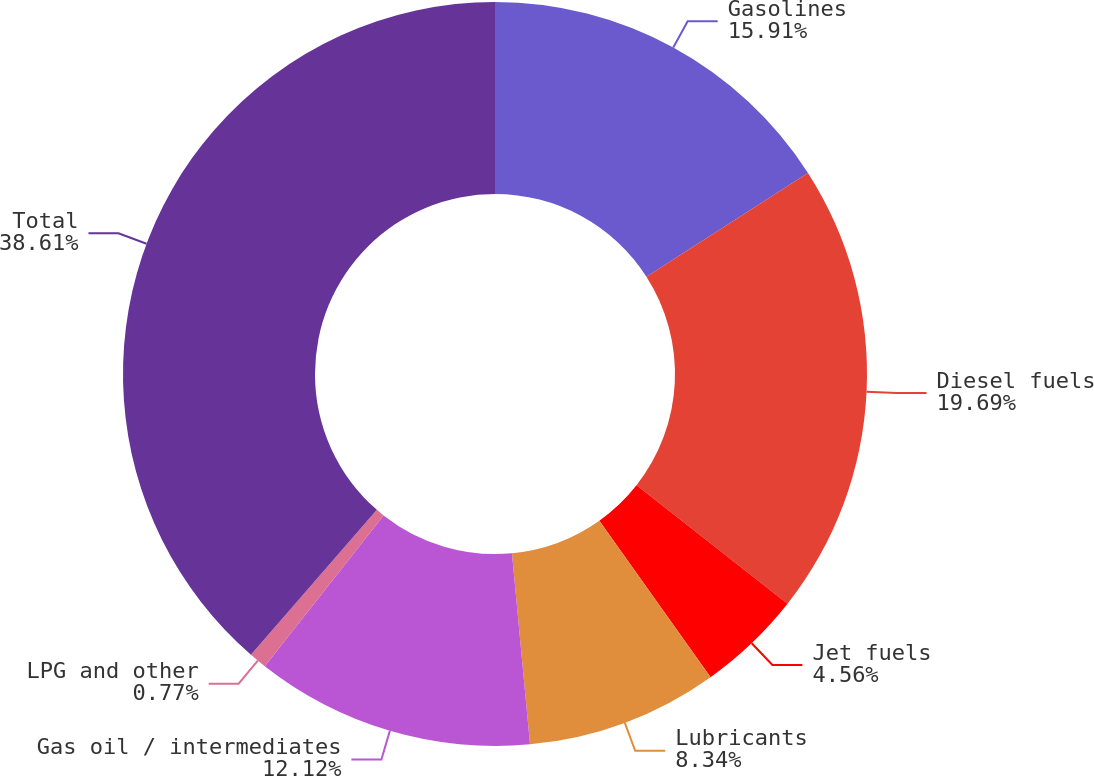<chart> <loc_0><loc_0><loc_500><loc_500><pie_chart><fcel>Gasolines<fcel>Diesel fuels<fcel>Jet fuels<fcel>Lubricants<fcel>Gas oil / intermediates<fcel>LPG and other<fcel>Total<nl><fcel>15.91%<fcel>19.69%<fcel>4.56%<fcel>8.34%<fcel>12.12%<fcel>0.77%<fcel>38.61%<nl></chart> 